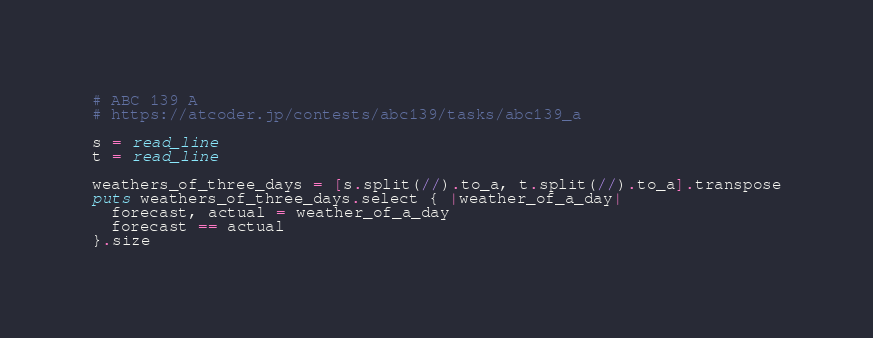<code> <loc_0><loc_0><loc_500><loc_500><_Crystal_># ABC 139 A
# https://atcoder.jp/contests/abc139/tasks/abc139_a

s = read_line
t = read_line

weathers_of_three_days = [s.split(//).to_a, t.split(//).to_a].transpose
puts weathers_of_three_days.select { |weather_of_a_day|
  forecast, actual = weather_of_a_day
  forecast == actual
}.size
</code> 